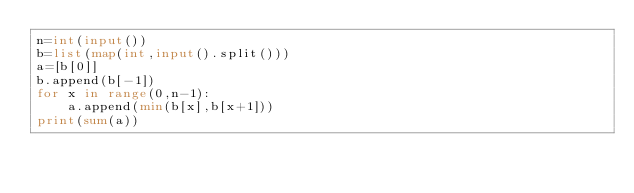<code> <loc_0><loc_0><loc_500><loc_500><_Python_>n=int(input())
b=list(map(int,input().split()))
a=[b[0]]
b.append(b[-1])
for x in range(0,n-1):
    a.append(min(b[x],b[x+1]))
print(sum(a))</code> 